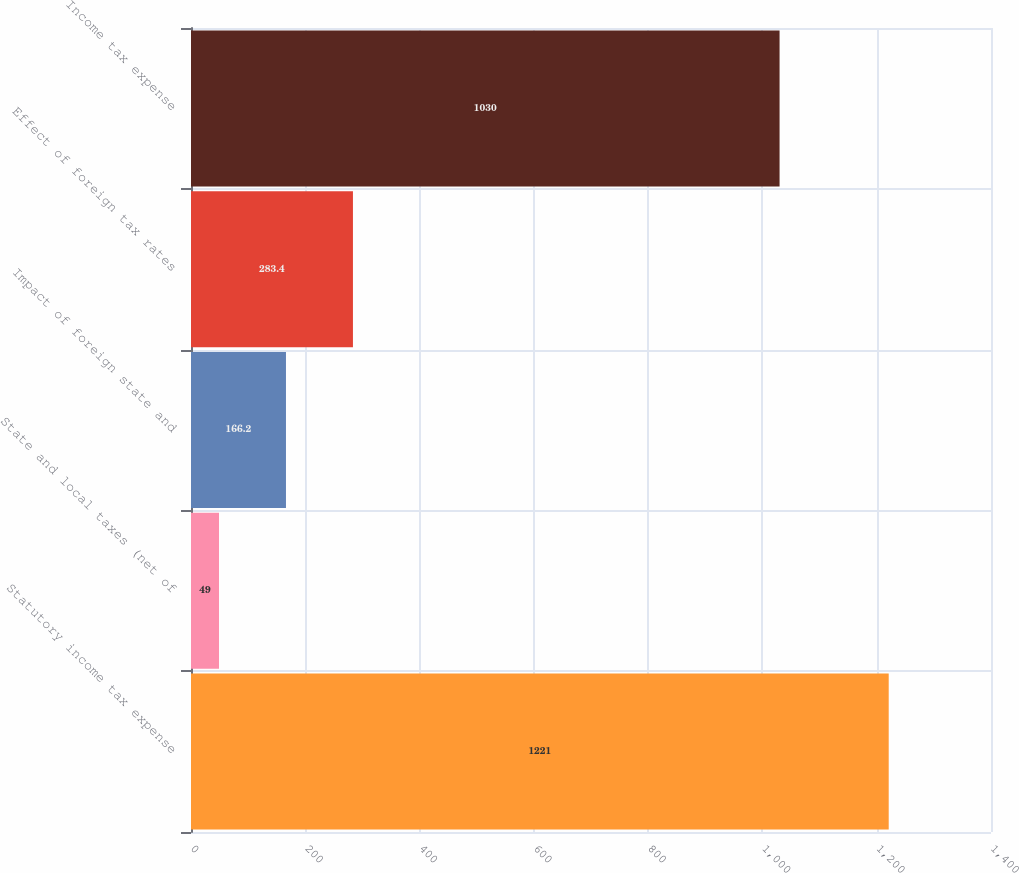Convert chart. <chart><loc_0><loc_0><loc_500><loc_500><bar_chart><fcel>Statutory income tax expense<fcel>State and local taxes (net of<fcel>Impact of foreign state and<fcel>Effect of foreign tax rates<fcel>Income tax expense<nl><fcel>1221<fcel>49<fcel>166.2<fcel>283.4<fcel>1030<nl></chart> 